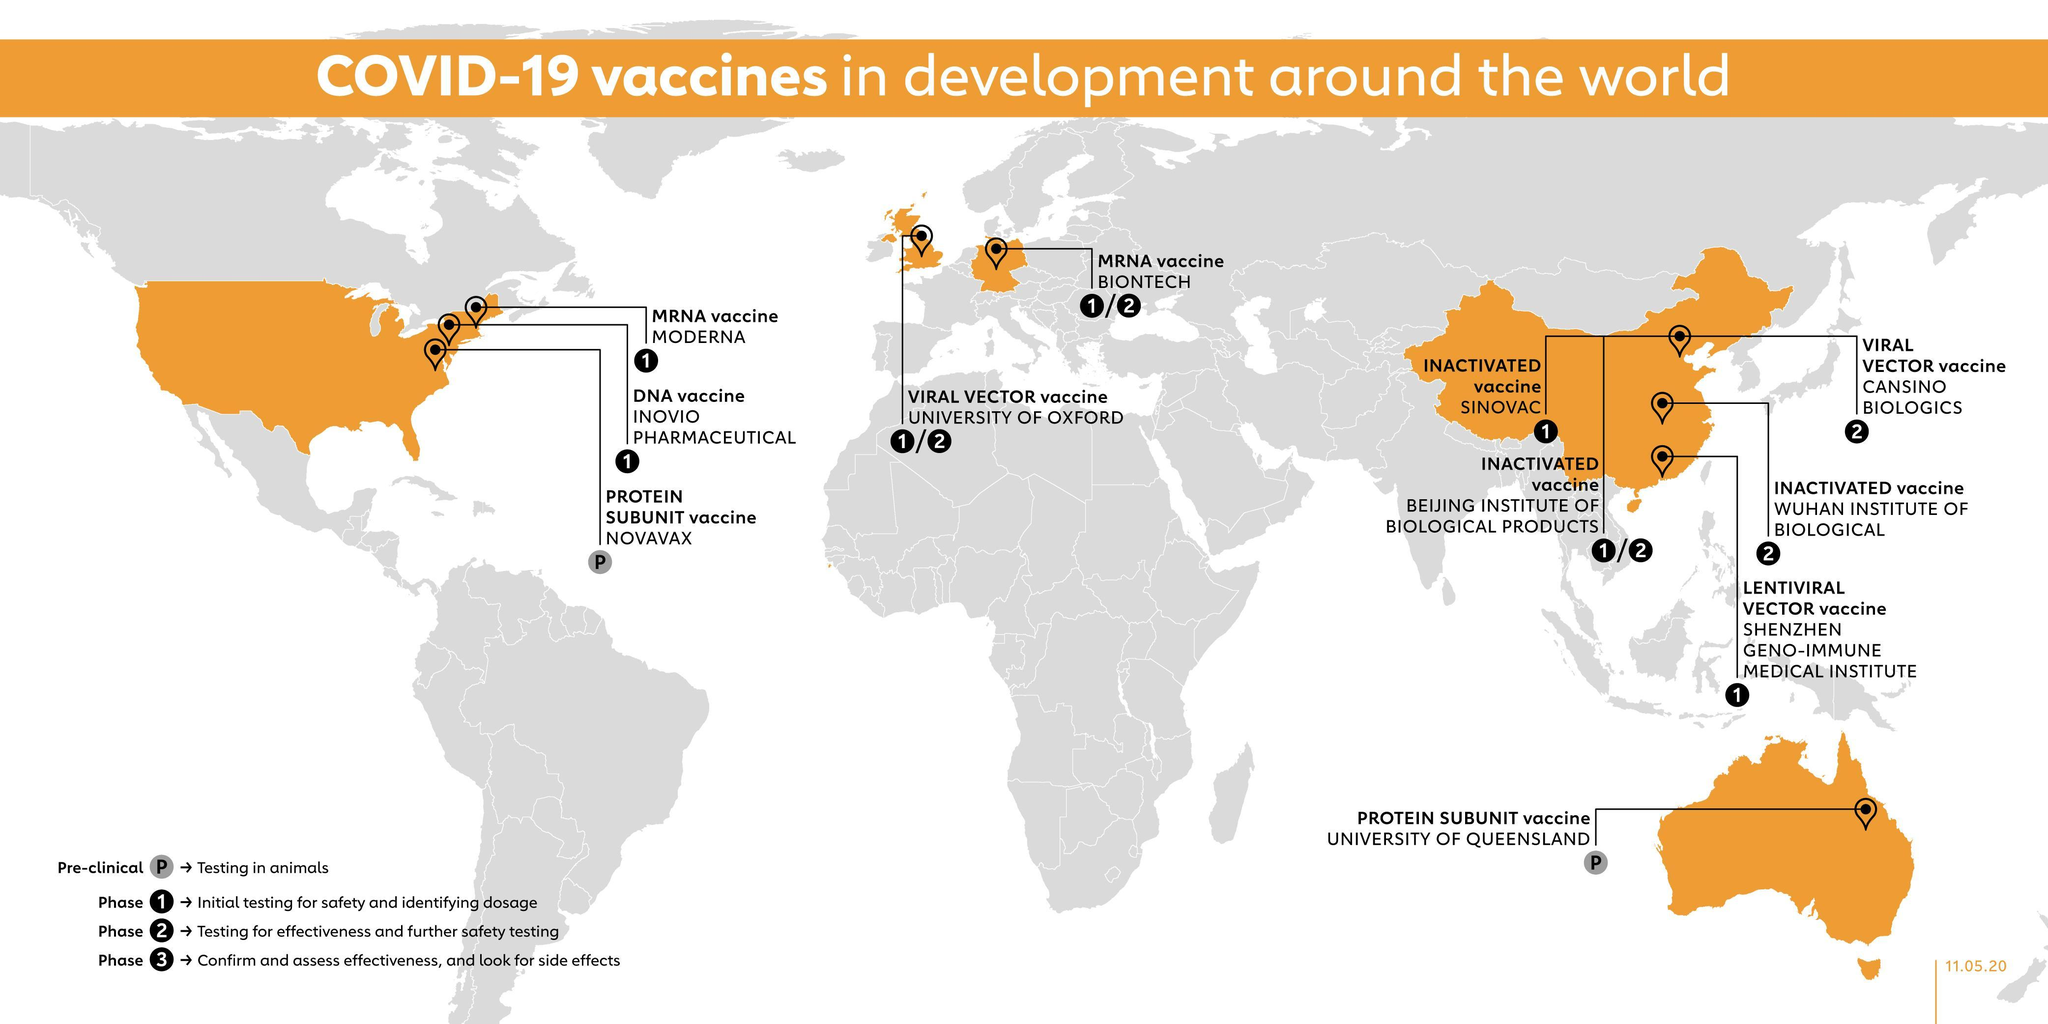Where is the pre-clinical trials of COVID-19 vaccine developed in Australia?
Answer the question with a short phrase. UNIVERSITY OF QUEENSLAND Where is the MRNA vaccine phase 1 & phase 2 trials for COVID-19 performed in Germany? BIONTECH Where is the Viral vector based COVID-19 vaccine phase 1 & phase 2 trials performed in the UK? UNIVERSITY OF OXFORD 